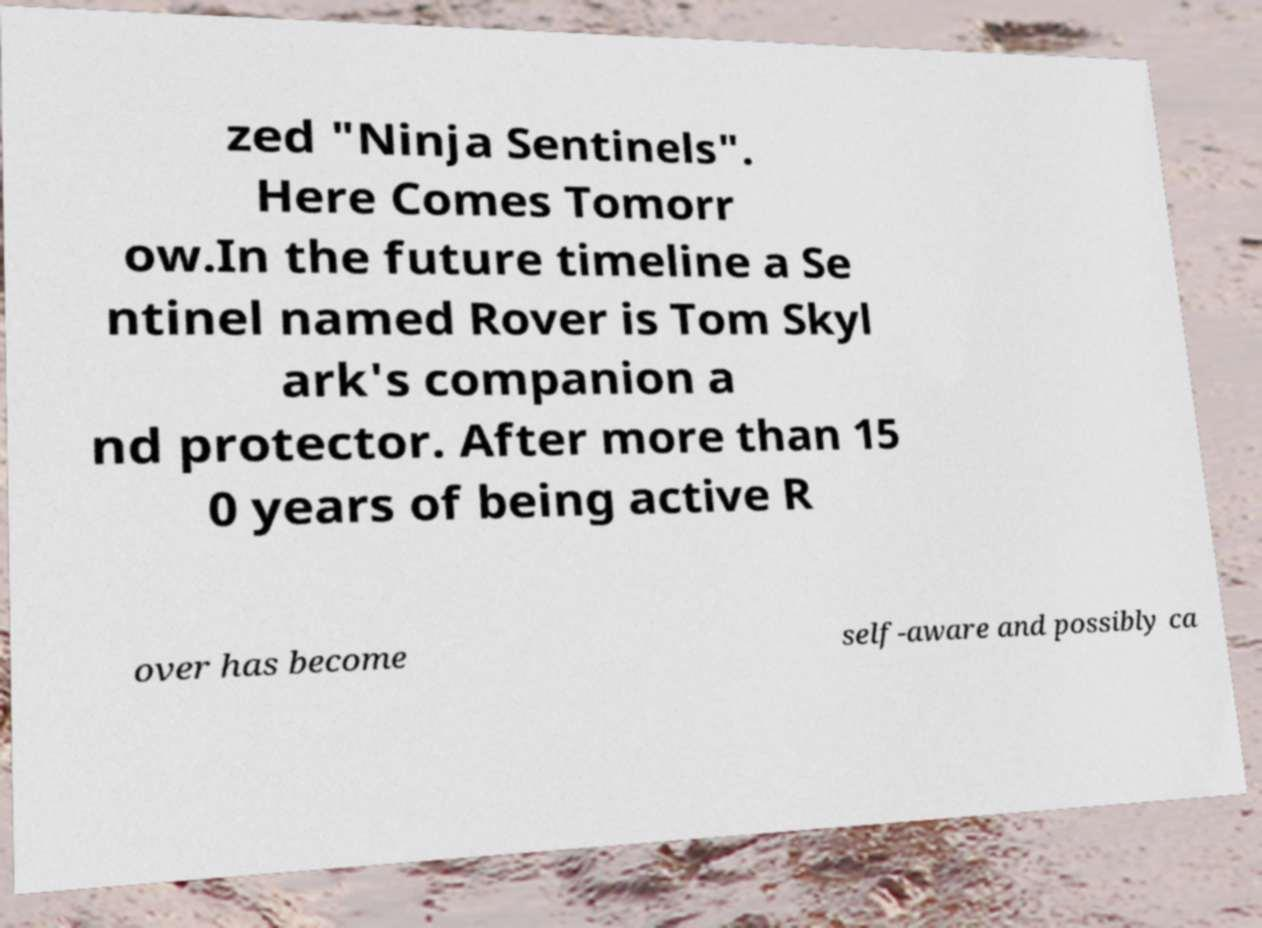Please read and relay the text visible in this image. What does it say? zed "Ninja Sentinels". Here Comes Tomorr ow.In the future timeline a Se ntinel named Rover is Tom Skyl ark's companion a nd protector. After more than 15 0 years of being active R over has become self-aware and possibly ca 